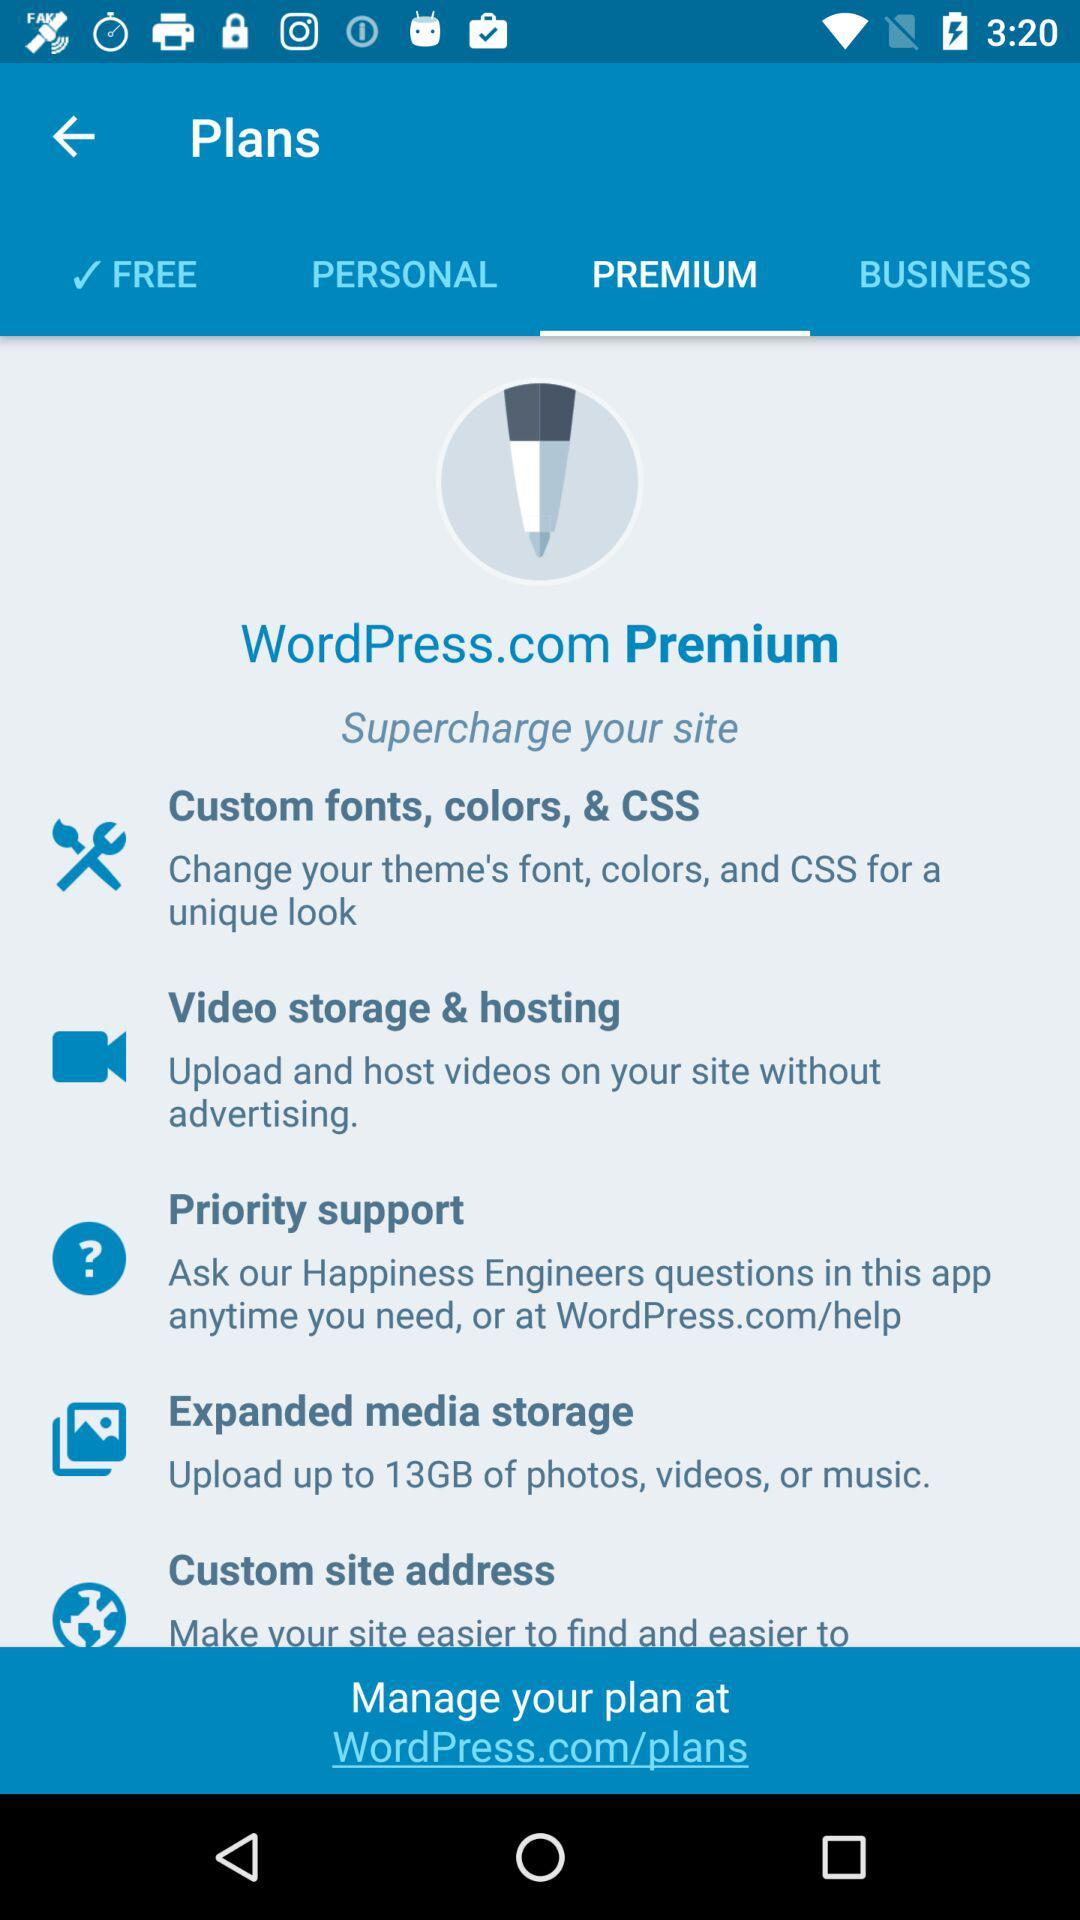What things do we upload to media storage? You can upload up to 13GB of photos, videos, or music to media storage. 